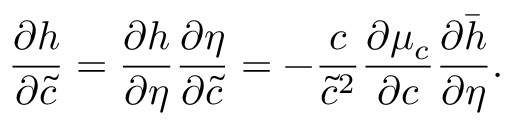Convert formula to latex. <formula><loc_0><loc_0><loc_500><loc_500>\frac { \partial h } { \partial \tilde { c } } = \frac { \partial h } { \partial \eta } \frac { \partial \eta } { \partial \tilde { c } } = - \frac { c } { \tilde { c } ^ { 2 } } \frac { \partial \mu _ { c } } { \partial c } \frac { \partial \bar { h } } { \partial \eta } .</formula> 